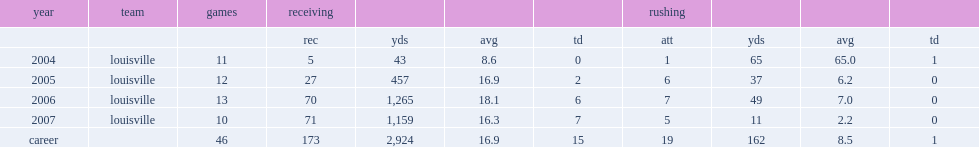How many receiving yards did douglas get in 2005? 457.0. Would you mind parsing the complete table? {'header': ['year', 'team', 'games', 'receiving', '', '', '', 'rushing', '', '', ''], 'rows': [['', '', '', 'rec', 'yds', 'avg', 'td', 'att', 'yds', 'avg', 'td'], ['2004', 'louisville', '11', '5', '43', '8.6', '0', '1', '65', '65.0', '1'], ['2005', 'louisville', '12', '27', '457', '16.9', '2', '6', '37', '6.2', '0'], ['2006', 'louisville', '13', '70', '1,265', '18.1', '6', '7', '49', '7.0', '0'], ['2007', 'louisville', '10', '71', '1,159', '16.3', '7', '5', '11', '2.2', '0'], ['career', '', '46', '173', '2,924', '16.9', '15', '19', '162', '8.5', '1']]} 